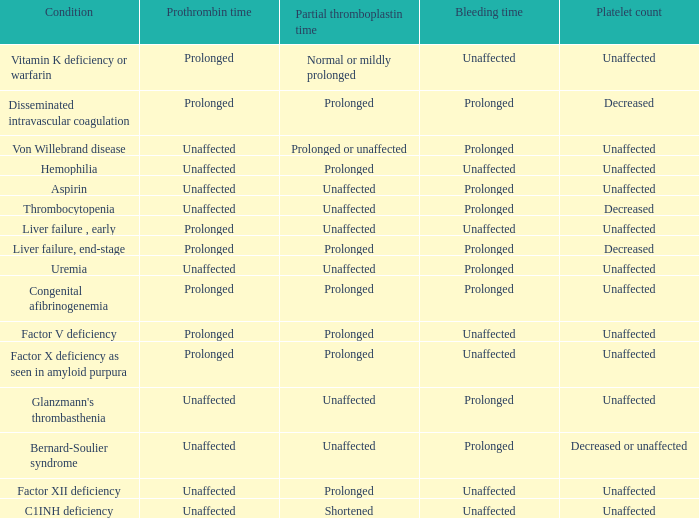What is the platelet count associated with bernard-soulier syndrome? Decreased or unaffected. Give me the full table as a dictionary. {'header': ['Condition', 'Prothrombin time', 'Partial thromboplastin time', 'Bleeding time', 'Platelet count'], 'rows': [['Vitamin K deficiency or warfarin', 'Prolonged', 'Normal or mildly prolonged', 'Unaffected', 'Unaffected'], ['Disseminated intravascular coagulation', 'Prolonged', 'Prolonged', 'Prolonged', 'Decreased'], ['Von Willebrand disease', 'Unaffected', 'Prolonged or unaffected', 'Prolonged', 'Unaffected'], ['Hemophilia', 'Unaffected', 'Prolonged', 'Unaffected', 'Unaffected'], ['Aspirin', 'Unaffected', 'Unaffected', 'Prolonged', 'Unaffected'], ['Thrombocytopenia', 'Unaffected', 'Unaffected', 'Prolonged', 'Decreased'], ['Liver failure , early', 'Prolonged', 'Unaffected', 'Unaffected', 'Unaffected'], ['Liver failure, end-stage', 'Prolonged', 'Prolonged', 'Prolonged', 'Decreased'], ['Uremia', 'Unaffected', 'Unaffected', 'Prolonged', 'Unaffected'], ['Congenital afibrinogenemia', 'Prolonged', 'Prolonged', 'Prolonged', 'Unaffected'], ['Factor V deficiency', 'Prolonged', 'Prolonged', 'Unaffected', 'Unaffected'], ['Factor X deficiency as seen in amyloid purpura', 'Prolonged', 'Prolonged', 'Unaffected', 'Unaffected'], ["Glanzmann's thrombasthenia", 'Unaffected', 'Unaffected', 'Prolonged', 'Unaffected'], ['Bernard-Soulier syndrome', 'Unaffected', 'Unaffected', 'Prolonged', 'Decreased or unaffected'], ['Factor XII deficiency', 'Unaffected', 'Prolonged', 'Unaffected', 'Unaffected'], ['C1INH deficiency', 'Unaffected', 'Shortened', 'Unaffected', 'Unaffected']]} 